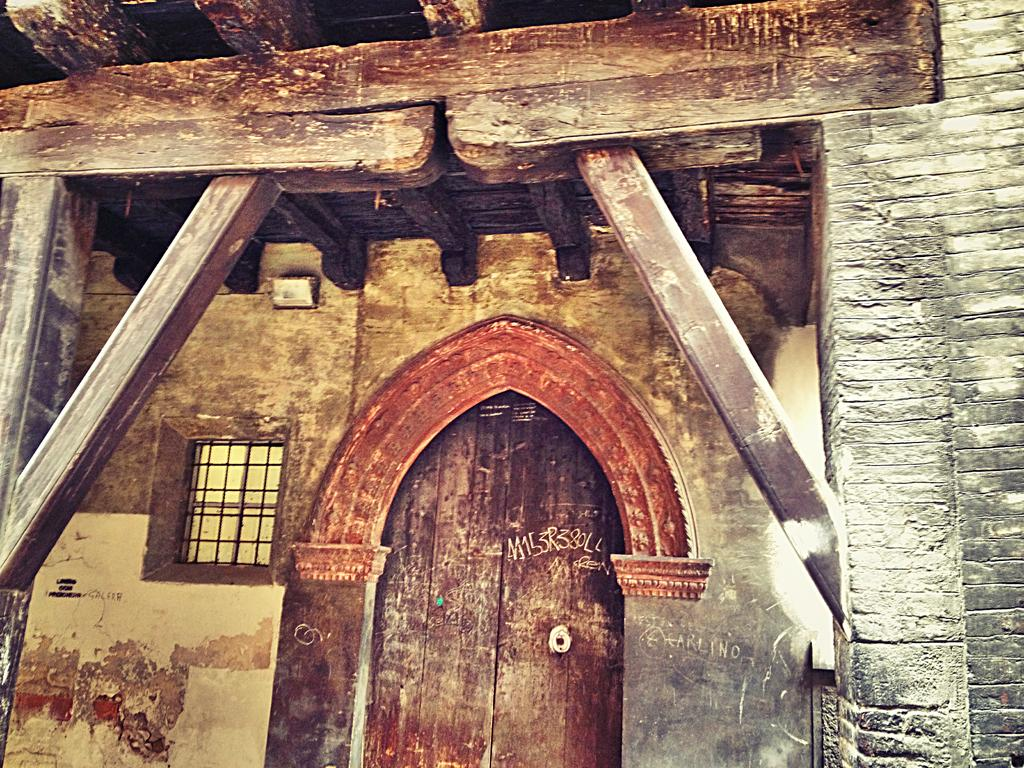What type of structure can be seen in the image? There is a wall in the image. What type of roof is present on the structure? There is a wooden roof in the image. What type of support can be seen in the image? There are wooden poles in the image. What type of entrance is present in the image? There is a door in the image. What type of opening for light and ventilation is present in the image? There is a window in the image. How much does the zebra weigh that is standing next to the structure in the image? There is no zebra present in the image. What type of assistance is the beggar providing to the people inside the structure in the image? There is no beggar present in the image. 